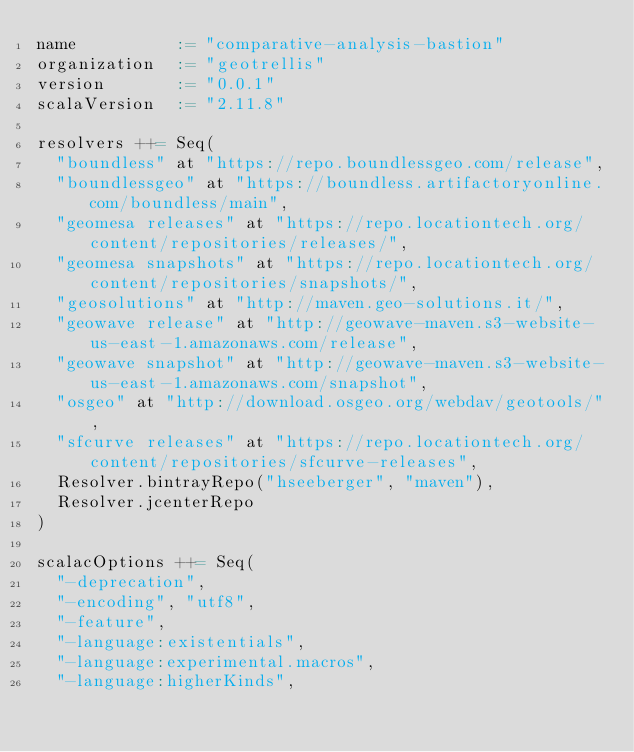<code> <loc_0><loc_0><loc_500><loc_500><_Scala_>name          := "comparative-analysis-bastion"
organization  := "geotrellis"
version       := "0.0.1"
scalaVersion  := "2.11.8"

resolvers ++= Seq(
  "boundless" at "https://repo.boundlessgeo.com/release",
  "boundlessgeo" at "https://boundless.artifactoryonline.com/boundless/main",
  "geomesa releases" at "https://repo.locationtech.org/content/repositories/releases/",
  "geomesa snapshots" at "https://repo.locationtech.org/content/repositories/snapshots/",
  "geosolutions" at "http://maven.geo-solutions.it/",
  "geowave release" at "http://geowave-maven.s3-website-us-east-1.amazonaws.com/release",
  "geowave snapshot" at "http://geowave-maven.s3-website-us-east-1.amazonaws.com/snapshot",
  "osgeo" at "http://download.osgeo.org/webdav/geotools/",
  "sfcurve releases" at "https://repo.locationtech.org/content/repositories/sfcurve-releases",
  Resolver.bintrayRepo("hseeberger", "maven"),
  Resolver.jcenterRepo
)

scalacOptions ++= Seq(
  "-deprecation",
  "-encoding", "utf8",
  "-feature",
  "-language:existentials",
  "-language:experimental.macros",
  "-language:higherKinds",</code> 